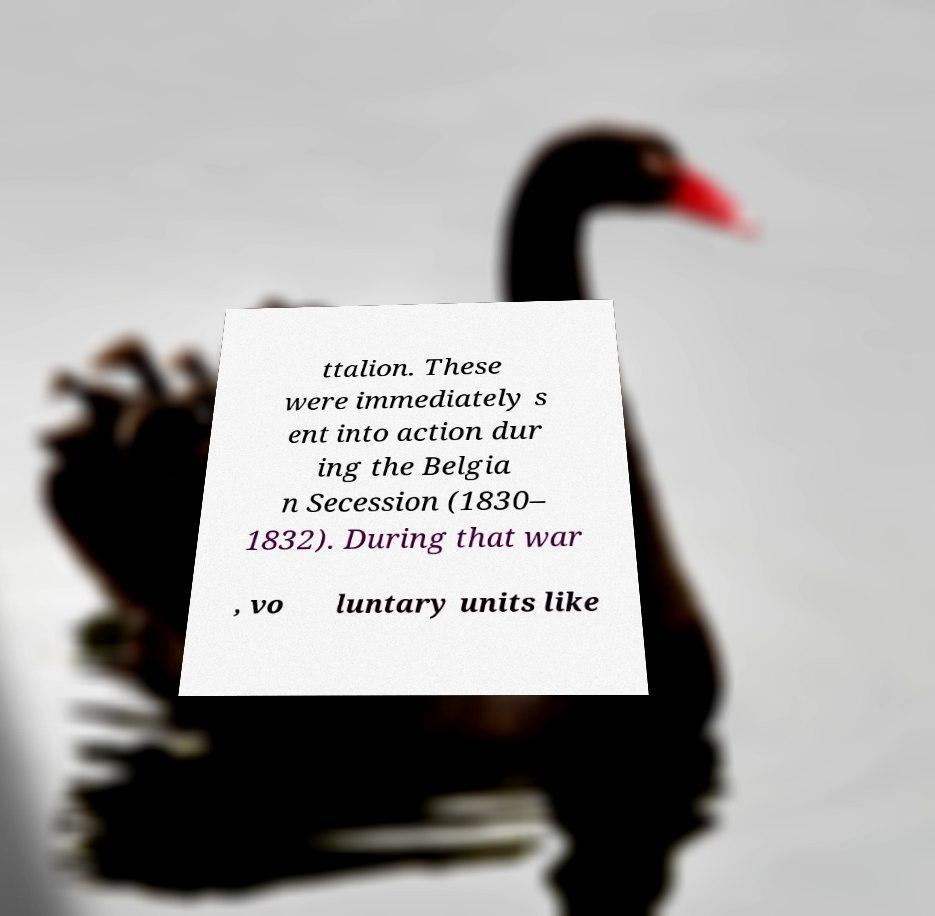For documentation purposes, I need the text within this image transcribed. Could you provide that? ttalion. These were immediately s ent into action dur ing the Belgia n Secession (1830– 1832). During that war , vo luntary units like 